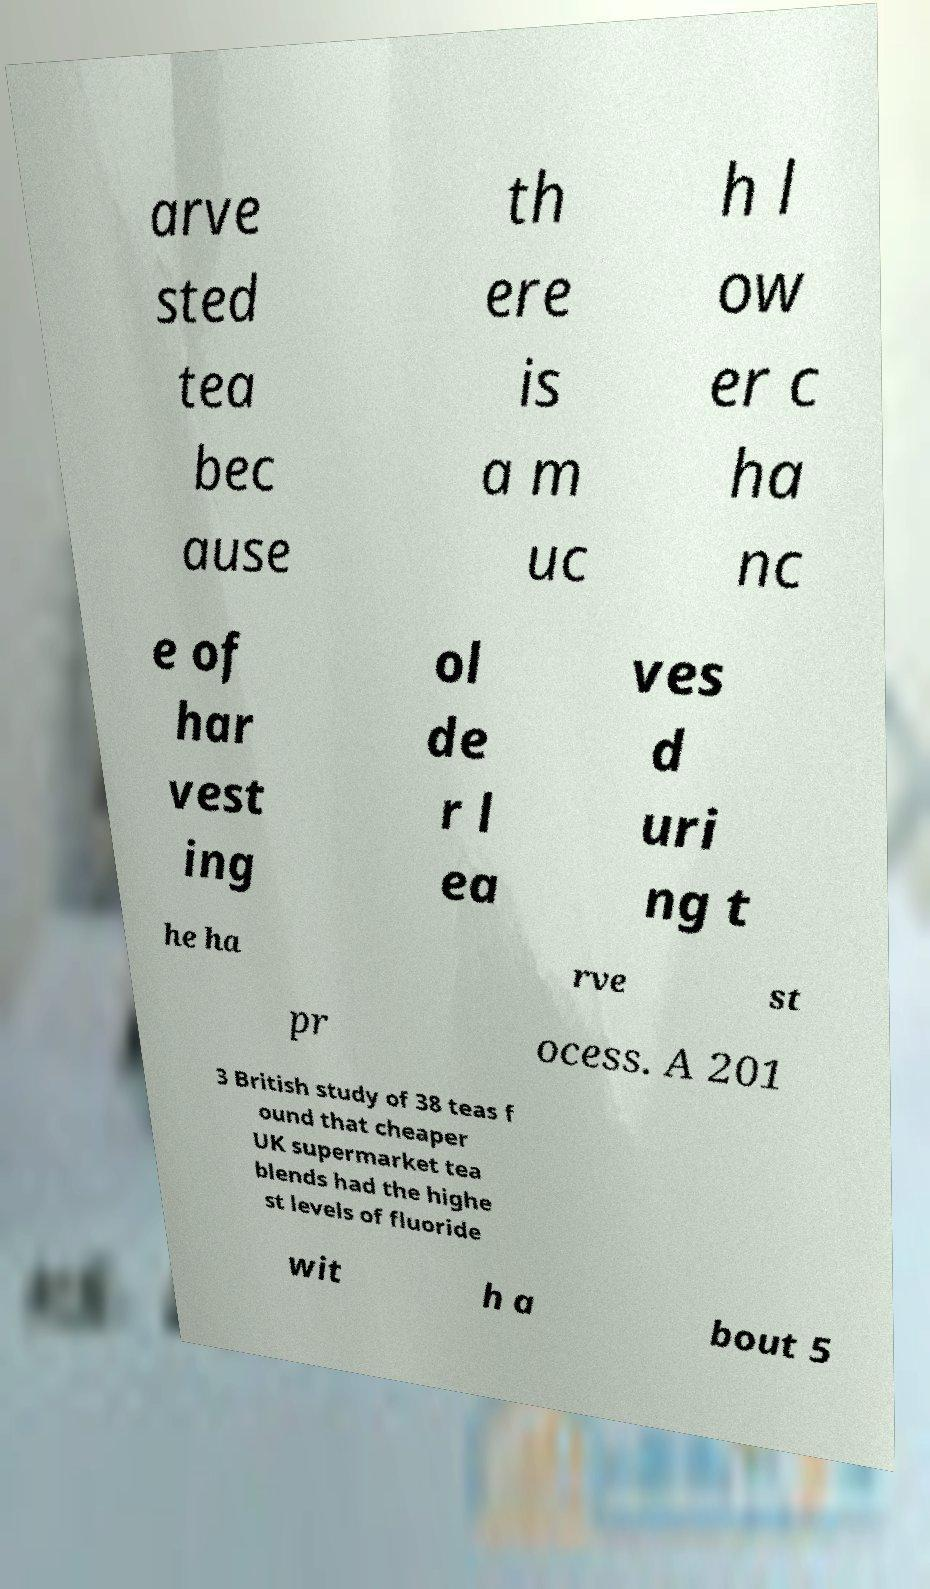Can you read and provide the text displayed in the image?This photo seems to have some interesting text. Can you extract and type it out for me? arve sted tea bec ause th ere is a m uc h l ow er c ha nc e of har vest ing ol de r l ea ves d uri ng t he ha rve st pr ocess. A 201 3 British study of 38 teas f ound that cheaper UK supermarket tea blends had the highe st levels of fluoride wit h a bout 5 